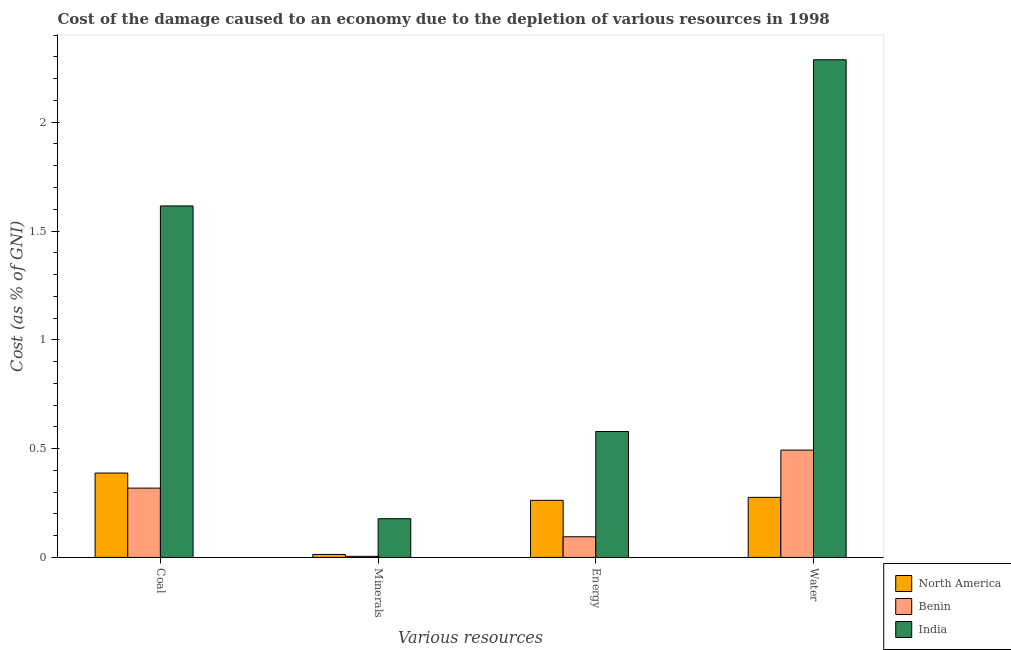How many different coloured bars are there?
Give a very brief answer. 3. Are the number of bars per tick equal to the number of legend labels?
Your response must be concise. Yes. How many bars are there on the 2nd tick from the left?
Offer a terse response. 3. How many bars are there on the 4th tick from the right?
Keep it short and to the point. 3. What is the label of the 1st group of bars from the left?
Keep it short and to the point. Coal. What is the cost of damage due to depletion of minerals in Benin?
Give a very brief answer. 0.01. Across all countries, what is the maximum cost of damage due to depletion of water?
Ensure brevity in your answer.  2.29. Across all countries, what is the minimum cost of damage due to depletion of water?
Your response must be concise. 0.28. In which country was the cost of damage due to depletion of energy maximum?
Ensure brevity in your answer.  India. What is the total cost of damage due to depletion of coal in the graph?
Your answer should be compact. 2.32. What is the difference between the cost of damage due to depletion of minerals in North America and that in India?
Provide a short and direct response. -0.16. What is the difference between the cost of damage due to depletion of water in India and the cost of damage due to depletion of coal in Benin?
Your answer should be very brief. 1.97. What is the average cost of damage due to depletion of minerals per country?
Offer a very short reply. 0.07. What is the difference between the cost of damage due to depletion of water and cost of damage due to depletion of coal in Benin?
Your answer should be compact. 0.17. What is the ratio of the cost of damage due to depletion of coal in North America to that in India?
Your answer should be compact. 0.24. Is the difference between the cost of damage due to depletion of water in North America and India greater than the difference between the cost of damage due to depletion of energy in North America and India?
Provide a succinct answer. No. What is the difference between the highest and the second highest cost of damage due to depletion of water?
Give a very brief answer. 1.79. What is the difference between the highest and the lowest cost of damage due to depletion of water?
Keep it short and to the point. 2.01. Is the sum of the cost of damage due to depletion of coal in Benin and India greater than the maximum cost of damage due to depletion of minerals across all countries?
Offer a very short reply. Yes. Is it the case that in every country, the sum of the cost of damage due to depletion of minerals and cost of damage due to depletion of energy is greater than the sum of cost of damage due to depletion of coal and cost of damage due to depletion of water?
Your answer should be very brief. No. What does the 3rd bar from the left in Coal represents?
Your answer should be very brief. India. How many bars are there?
Your answer should be very brief. 12. Are all the bars in the graph horizontal?
Ensure brevity in your answer.  No. How many countries are there in the graph?
Give a very brief answer. 3. What is the difference between two consecutive major ticks on the Y-axis?
Offer a terse response. 0.5. Are the values on the major ticks of Y-axis written in scientific E-notation?
Provide a succinct answer. No. Does the graph contain grids?
Keep it short and to the point. No. Where does the legend appear in the graph?
Provide a short and direct response. Bottom right. What is the title of the graph?
Give a very brief answer. Cost of the damage caused to an economy due to the depletion of various resources in 1998 . Does "Sint Maarten (Dutch part)" appear as one of the legend labels in the graph?
Provide a short and direct response. No. What is the label or title of the X-axis?
Ensure brevity in your answer.  Various resources. What is the label or title of the Y-axis?
Make the answer very short. Cost (as % of GNI). What is the Cost (as % of GNI) of North America in Coal?
Offer a terse response. 0.39. What is the Cost (as % of GNI) in Benin in Coal?
Your answer should be compact. 0.32. What is the Cost (as % of GNI) of India in Coal?
Provide a succinct answer. 1.62. What is the Cost (as % of GNI) of North America in Minerals?
Your answer should be compact. 0.01. What is the Cost (as % of GNI) in Benin in Minerals?
Provide a succinct answer. 0.01. What is the Cost (as % of GNI) of India in Minerals?
Provide a short and direct response. 0.18. What is the Cost (as % of GNI) in North America in Energy?
Provide a succinct answer. 0.26. What is the Cost (as % of GNI) of Benin in Energy?
Provide a short and direct response. 0.09. What is the Cost (as % of GNI) in India in Energy?
Provide a short and direct response. 0.58. What is the Cost (as % of GNI) of North America in Water?
Provide a short and direct response. 0.28. What is the Cost (as % of GNI) of Benin in Water?
Your answer should be very brief. 0.49. What is the Cost (as % of GNI) of India in Water?
Give a very brief answer. 2.29. Across all Various resources, what is the maximum Cost (as % of GNI) in North America?
Offer a terse response. 0.39. Across all Various resources, what is the maximum Cost (as % of GNI) in Benin?
Ensure brevity in your answer.  0.49. Across all Various resources, what is the maximum Cost (as % of GNI) of India?
Provide a short and direct response. 2.29. Across all Various resources, what is the minimum Cost (as % of GNI) of North America?
Offer a very short reply. 0.01. Across all Various resources, what is the minimum Cost (as % of GNI) of Benin?
Offer a terse response. 0.01. Across all Various resources, what is the minimum Cost (as % of GNI) of India?
Ensure brevity in your answer.  0.18. What is the total Cost (as % of GNI) of North America in the graph?
Keep it short and to the point. 0.94. What is the total Cost (as % of GNI) in Benin in the graph?
Your answer should be very brief. 0.91. What is the total Cost (as % of GNI) of India in the graph?
Ensure brevity in your answer.  4.66. What is the difference between the Cost (as % of GNI) in North America in Coal and that in Minerals?
Keep it short and to the point. 0.37. What is the difference between the Cost (as % of GNI) in Benin in Coal and that in Minerals?
Give a very brief answer. 0.31. What is the difference between the Cost (as % of GNI) of India in Coal and that in Minerals?
Ensure brevity in your answer.  1.44. What is the difference between the Cost (as % of GNI) of North America in Coal and that in Energy?
Provide a succinct answer. 0.13. What is the difference between the Cost (as % of GNI) of Benin in Coal and that in Energy?
Make the answer very short. 0.22. What is the difference between the Cost (as % of GNI) of India in Coal and that in Energy?
Give a very brief answer. 1.04. What is the difference between the Cost (as % of GNI) of North America in Coal and that in Water?
Make the answer very short. 0.11. What is the difference between the Cost (as % of GNI) in Benin in Coal and that in Water?
Keep it short and to the point. -0.17. What is the difference between the Cost (as % of GNI) of India in Coal and that in Water?
Provide a succinct answer. -0.67. What is the difference between the Cost (as % of GNI) of North America in Minerals and that in Energy?
Provide a succinct answer. -0.25. What is the difference between the Cost (as % of GNI) in Benin in Minerals and that in Energy?
Provide a short and direct response. -0.09. What is the difference between the Cost (as % of GNI) of India in Minerals and that in Energy?
Keep it short and to the point. -0.4. What is the difference between the Cost (as % of GNI) of North America in Minerals and that in Water?
Keep it short and to the point. -0.26. What is the difference between the Cost (as % of GNI) in Benin in Minerals and that in Water?
Offer a terse response. -0.49. What is the difference between the Cost (as % of GNI) of India in Minerals and that in Water?
Your response must be concise. -2.11. What is the difference between the Cost (as % of GNI) in North America in Energy and that in Water?
Provide a succinct answer. -0.01. What is the difference between the Cost (as % of GNI) in Benin in Energy and that in Water?
Provide a succinct answer. -0.4. What is the difference between the Cost (as % of GNI) of India in Energy and that in Water?
Offer a terse response. -1.71. What is the difference between the Cost (as % of GNI) in North America in Coal and the Cost (as % of GNI) in Benin in Minerals?
Give a very brief answer. 0.38. What is the difference between the Cost (as % of GNI) in North America in Coal and the Cost (as % of GNI) in India in Minerals?
Give a very brief answer. 0.21. What is the difference between the Cost (as % of GNI) of Benin in Coal and the Cost (as % of GNI) of India in Minerals?
Your response must be concise. 0.14. What is the difference between the Cost (as % of GNI) in North America in Coal and the Cost (as % of GNI) in Benin in Energy?
Provide a short and direct response. 0.29. What is the difference between the Cost (as % of GNI) of North America in Coal and the Cost (as % of GNI) of India in Energy?
Make the answer very short. -0.19. What is the difference between the Cost (as % of GNI) of Benin in Coal and the Cost (as % of GNI) of India in Energy?
Offer a very short reply. -0.26. What is the difference between the Cost (as % of GNI) of North America in Coal and the Cost (as % of GNI) of Benin in Water?
Your answer should be compact. -0.11. What is the difference between the Cost (as % of GNI) in North America in Coal and the Cost (as % of GNI) in India in Water?
Offer a very short reply. -1.9. What is the difference between the Cost (as % of GNI) in Benin in Coal and the Cost (as % of GNI) in India in Water?
Your response must be concise. -1.97. What is the difference between the Cost (as % of GNI) in North America in Minerals and the Cost (as % of GNI) in Benin in Energy?
Your response must be concise. -0.08. What is the difference between the Cost (as % of GNI) of North America in Minerals and the Cost (as % of GNI) of India in Energy?
Ensure brevity in your answer.  -0.57. What is the difference between the Cost (as % of GNI) of Benin in Minerals and the Cost (as % of GNI) of India in Energy?
Provide a succinct answer. -0.57. What is the difference between the Cost (as % of GNI) in North America in Minerals and the Cost (as % of GNI) in Benin in Water?
Keep it short and to the point. -0.48. What is the difference between the Cost (as % of GNI) of North America in Minerals and the Cost (as % of GNI) of India in Water?
Make the answer very short. -2.27. What is the difference between the Cost (as % of GNI) in Benin in Minerals and the Cost (as % of GNI) in India in Water?
Provide a short and direct response. -2.28. What is the difference between the Cost (as % of GNI) in North America in Energy and the Cost (as % of GNI) in Benin in Water?
Keep it short and to the point. -0.23. What is the difference between the Cost (as % of GNI) of North America in Energy and the Cost (as % of GNI) of India in Water?
Provide a short and direct response. -2.02. What is the difference between the Cost (as % of GNI) of Benin in Energy and the Cost (as % of GNI) of India in Water?
Make the answer very short. -2.19. What is the average Cost (as % of GNI) in North America per Various resources?
Provide a short and direct response. 0.23. What is the average Cost (as % of GNI) in Benin per Various resources?
Ensure brevity in your answer.  0.23. What is the average Cost (as % of GNI) of India per Various resources?
Your response must be concise. 1.16. What is the difference between the Cost (as % of GNI) of North America and Cost (as % of GNI) of Benin in Coal?
Your answer should be very brief. 0.07. What is the difference between the Cost (as % of GNI) in North America and Cost (as % of GNI) in India in Coal?
Your answer should be very brief. -1.23. What is the difference between the Cost (as % of GNI) of Benin and Cost (as % of GNI) of India in Coal?
Make the answer very short. -1.3. What is the difference between the Cost (as % of GNI) of North America and Cost (as % of GNI) of Benin in Minerals?
Give a very brief answer. 0.01. What is the difference between the Cost (as % of GNI) in North America and Cost (as % of GNI) in India in Minerals?
Your answer should be very brief. -0.16. What is the difference between the Cost (as % of GNI) in Benin and Cost (as % of GNI) in India in Minerals?
Offer a terse response. -0.17. What is the difference between the Cost (as % of GNI) of North America and Cost (as % of GNI) of Benin in Energy?
Ensure brevity in your answer.  0.17. What is the difference between the Cost (as % of GNI) in North America and Cost (as % of GNI) in India in Energy?
Provide a short and direct response. -0.32. What is the difference between the Cost (as % of GNI) of Benin and Cost (as % of GNI) of India in Energy?
Your response must be concise. -0.48. What is the difference between the Cost (as % of GNI) in North America and Cost (as % of GNI) in Benin in Water?
Keep it short and to the point. -0.22. What is the difference between the Cost (as % of GNI) in North America and Cost (as % of GNI) in India in Water?
Offer a terse response. -2.01. What is the difference between the Cost (as % of GNI) of Benin and Cost (as % of GNI) of India in Water?
Make the answer very short. -1.79. What is the ratio of the Cost (as % of GNI) in North America in Coal to that in Minerals?
Offer a very short reply. 28.35. What is the ratio of the Cost (as % of GNI) in Benin in Coal to that in Minerals?
Your response must be concise. 63.3. What is the ratio of the Cost (as % of GNI) of India in Coal to that in Minerals?
Your response must be concise. 9.08. What is the ratio of the Cost (as % of GNI) of North America in Coal to that in Energy?
Offer a terse response. 1.48. What is the ratio of the Cost (as % of GNI) in Benin in Coal to that in Energy?
Keep it short and to the point. 3.36. What is the ratio of the Cost (as % of GNI) of India in Coal to that in Energy?
Provide a succinct answer. 2.79. What is the ratio of the Cost (as % of GNI) in North America in Coal to that in Water?
Give a very brief answer. 1.4. What is the ratio of the Cost (as % of GNI) of Benin in Coal to that in Water?
Provide a succinct answer. 0.65. What is the ratio of the Cost (as % of GNI) of India in Coal to that in Water?
Make the answer very short. 0.71. What is the ratio of the Cost (as % of GNI) in North America in Minerals to that in Energy?
Provide a short and direct response. 0.05. What is the ratio of the Cost (as % of GNI) in Benin in Minerals to that in Energy?
Provide a short and direct response. 0.05. What is the ratio of the Cost (as % of GNI) in India in Minerals to that in Energy?
Give a very brief answer. 0.31. What is the ratio of the Cost (as % of GNI) of North America in Minerals to that in Water?
Offer a terse response. 0.05. What is the ratio of the Cost (as % of GNI) in Benin in Minerals to that in Water?
Make the answer very short. 0.01. What is the ratio of the Cost (as % of GNI) of India in Minerals to that in Water?
Provide a succinct answer. 0.08. What is the ratio of the Cost (as % of GNI) in North America in Energy to that in Water?
Your answer should be very brief. 0.95. What is the ratio of the Cost (as % of GNI) of Benin in Energy to that in Water?
Your answer should be compact. 0.19. What is the ratio of the Cost (as % of GNI) in India in Energy to that in Water?
Provide a short and direct response. 0.25. What is the difference between the highest and the second highest Cost (as % of GNI) in North America?
Your response must be concise. 0.11. What is the difference between the highest and the second highest Cost (as % of GNI) in Benin?
Provide a succinct answer. 0.17. What is the difference between the highest and the second highest Cost (as % of GNI) in India?
Make the answer very short. 0.67. What is the difference between the highest and the lowest Cost (as % of GNI) of North America?
Offer a very short reply. 0.37. What is the difference between the highest and the lowest Cost (as % of GNI) in Benin?
Provide a succinct answer. 0.49. What is the difference between the highest and the lowest Cost (as % of GNI) of India?
Offer a very short reply. 2.11. 